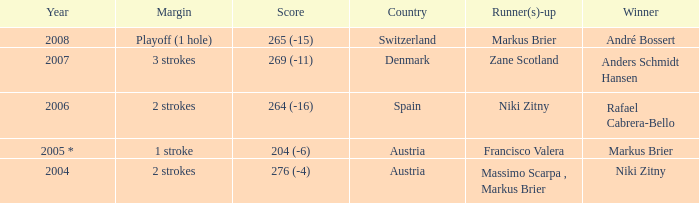In what year was the score 204 (-6)? 2005 *. Give me the full table as a dictionary. {'header': ['Year', 'Margin', 'Score', 'Country', 'Runner(s)-up', 'Winner'], 'rows': [['2008', 'Playoff (1 hole)', '265 (-15)', 'Switzerland', 'Markus Brier', 'André Bossert'], ['2007', '3 strokes', '269 (-11)', 'Denmark', 'Zane Scotland', 'Anders Schmidt Hansen'], ['2006', '2 strokes', '264 (-16)', 'Spain', 'Niki Zitny', 'Rafael Cabrera-Bello'], ['2005 *', '1 stroke', '204 (-6)', 'Austria', 'Francisco Valera', 'Markus Brier'], ['2004', '2 strokes', '276 (-4)', 'Austria', 'Massimo Scarpa , Markus Brier', 'Niki Zitny']]} 